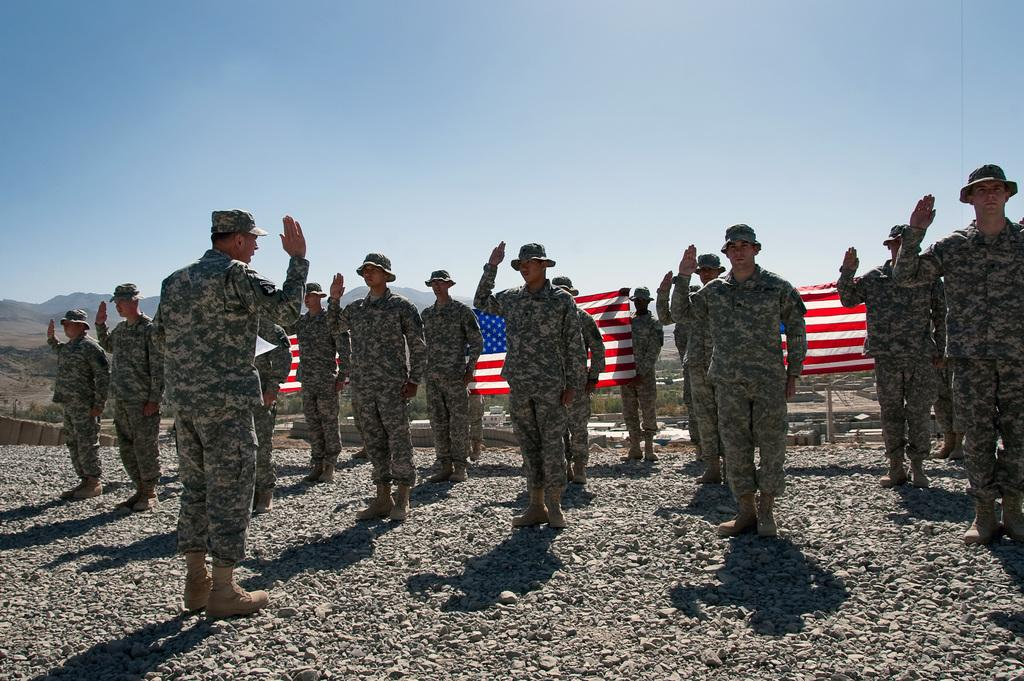What type of objects can be seen in the image? There are stones in the image. Are there any living beings in the image? Yes, there are people in the image. What are the people wearing? The people are wearing clothes. What type of headwear can be seen on the people? The people have caps on their heads. What is the condition of the sky in the image? The sky is clear in the image. What type of jelly can be seen on the stones in the image? There is no jelly present on the stones in the image. What type of string is being used to tie the people's hands together in the image? There is no indication in the image that the people's hands are tied together, nor is there any string visible. 